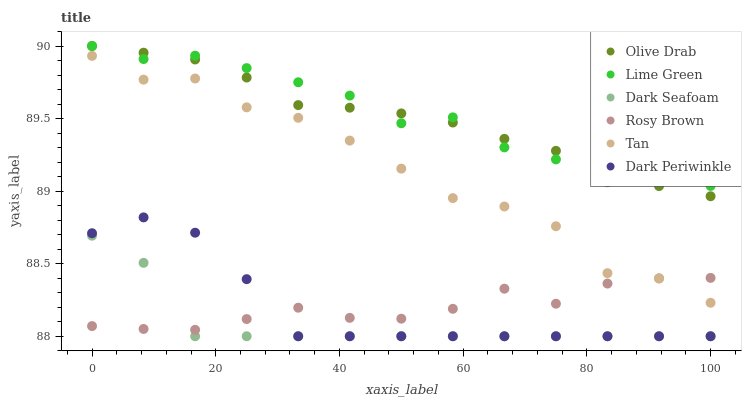Does Dark Seafoam have the minimum area under the curve?
Answer yes or no. Yes. Does Lime Green have the maximum area under the curve?
Answer yes or no. Yes. Does Tan have the minimum area under the curve?
Answer yes or no. No. Does Tan have the maximum area under the curve?
Answer yes or no. No. Is Olive Drab the smoothest?
Answer yes or no. Yes. Is Tan the roughest?
Answer yes or no. Yes. Is Dark Seafoam the smoothest?
Answer yes or no. No. Is Dark Seafoam the roughest?
Answer yes or no. No. Does Dark Seafoam have the lowest value?
Answer yes or no. Yes. Does Tan have the lowest value?
Answer yes or no. No. Does Olive Drab have the highest value?
Answer yes or no. Yes. Does Dark Seafoam have the highest value?
Answer yes or no. No. Is Dark Periwinkle less than Tan?
Answer yes or no. Yes. Is Lime Green greater than Tan?
Answer yes or no. Yes. Does Lime Green intersect Olive Drab?
Answer yes or no. Yes. Is Lime Green less than Olive Drab?
Answer yes or no. No. Is Lime Green greater than Olive Drab?
Answer yes or no. No. Does Dark Periwinkle intersect Tan?
Answer yes or no. No. 